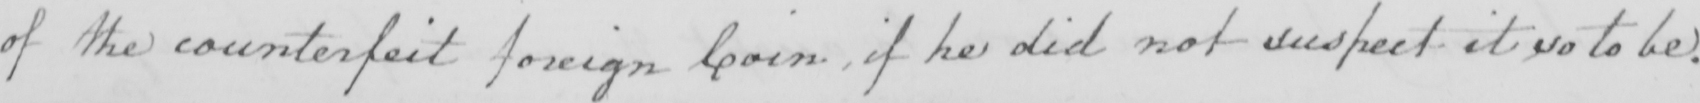Can you tell me what this handwritten text says? of the counterfeit foreign Coin  , if he did not suspect it so to be . 